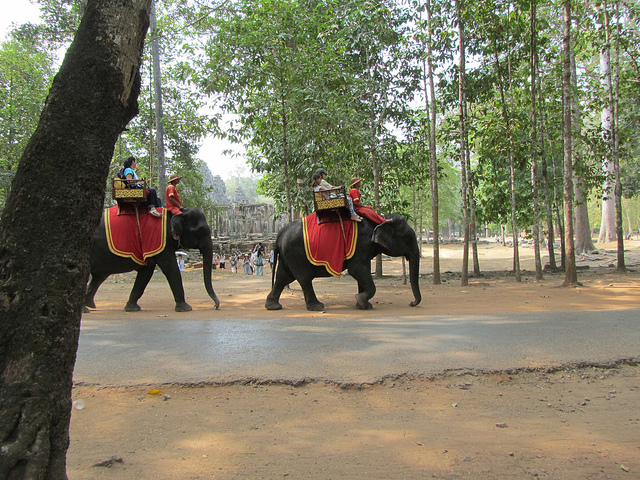What might be the purpose of the elephants in this setting? The elephants, equipped with seats and handlers, seem to be used for guided tours around the area, providing tourists with a unique way to experience the surroundings and contributing to the local tourist economy. How do people generally ensure the welfare of elephants used in tourism? Organizations and guidelines exist to promote the ethical treatment of elephants in tourism. This includes providing proper veterinary care, adequate rest periods, a natural and spacious environment, and a nutritious diet, as well as limiting the hours they work and the weight they carry. 